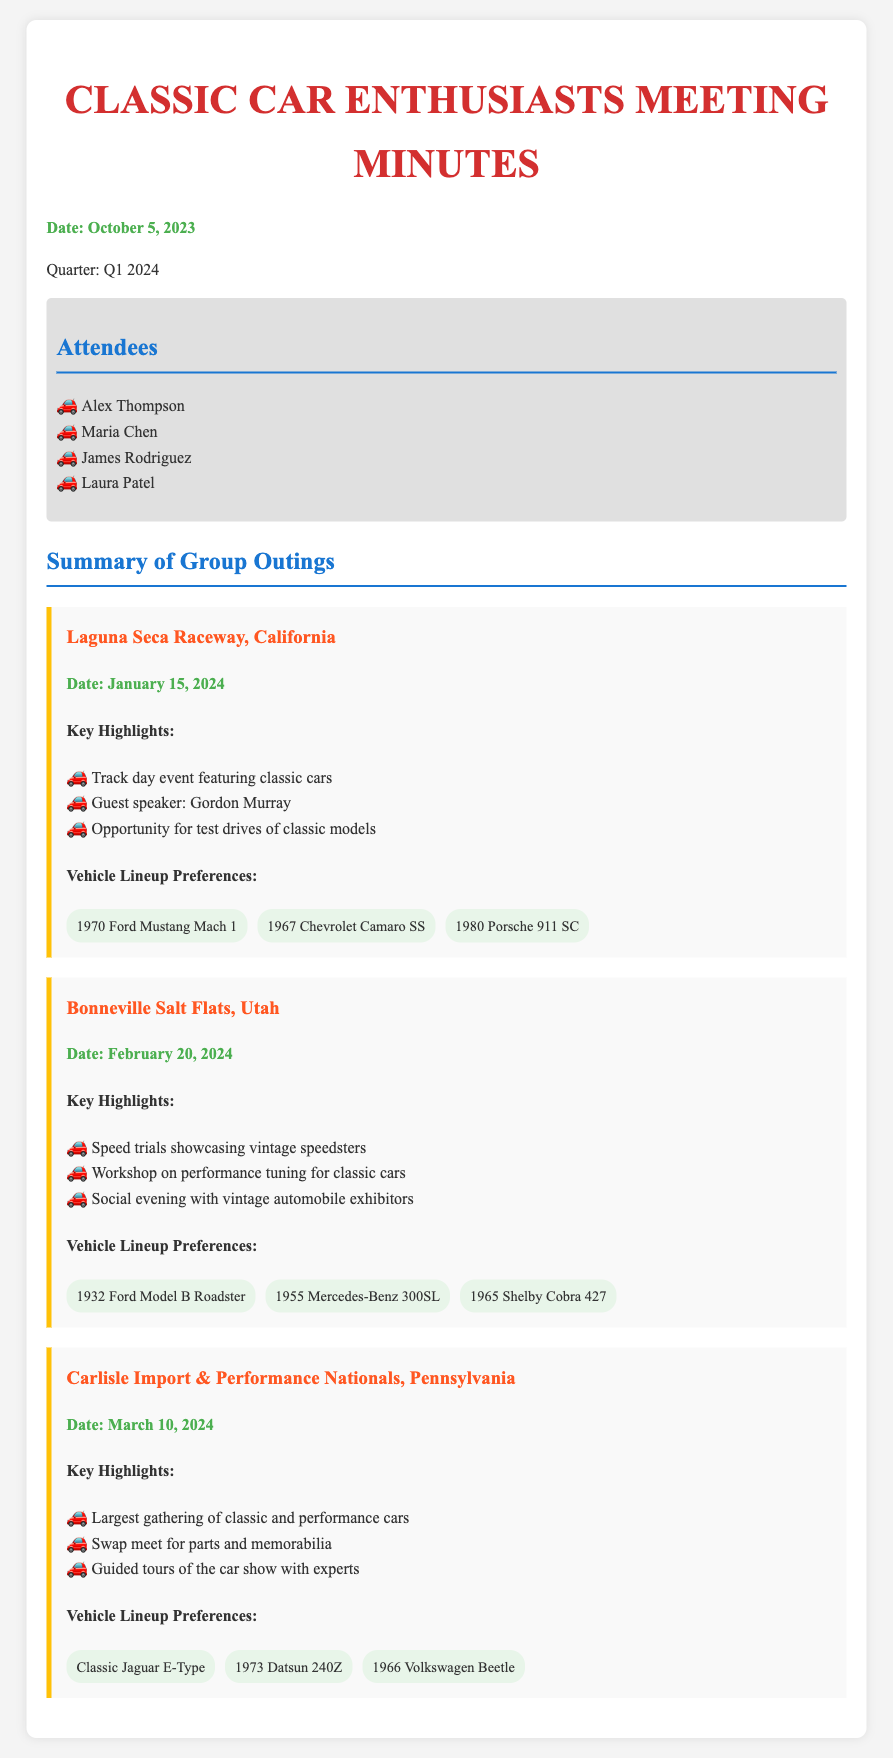What is the date of the outing at Laguna Seca Raceway? The document specifies that the outing at Laguna Seca Raceway is scheduled for January 15, 2024.
Answer: January 15, 2024 Who is the guest speaker at Laguna Seca Raceway? According to the document, the guest speaker for the event at Laguna Seca Raceway is Gordon Murray.
Answer: Gordon Murray How many vehicles are listed for the Bonneville Salt Flats outing? The document provides a list of three vehicles for the Bonneville Salt Flats outing, including the 1932 Ford Model B Roadster, 1955 Mercedes-Benz 300SL, and 1965 Shelby Cobra 427.
Answer: 3 What event occurs on February 20, 2024? The document describes a speed trials event showcasing vintage speedsters on February 20, 2024, at Bonneville Salt Flats.
Answer: Speed trials Which outing includes a workshop on performance tuning? The document states that the Bonneville Salt Flats outing includes a workshop on performance tuning for classic cars.
Answer: Bonneville Salt Flats What is the title of the meeting document? The title of the document is "Classic Car Enthusiasts Meeting Minutes".
Answer: Classic Car Enthusiasts Meeting Minutes Which classic car model is mentioned for the March outing? The document lists several classic car models for the Carlisle Import & Performance Nationals, including the Classic Jaguar E-Type, which is mentioned for the March outing.
Answer: Classic Jaguar E-Type When does the quarter being summarized in the document begin? The document specifies that the quarter being summarized is Q1 2024, which begins in January.
Answer: Q1 2024 